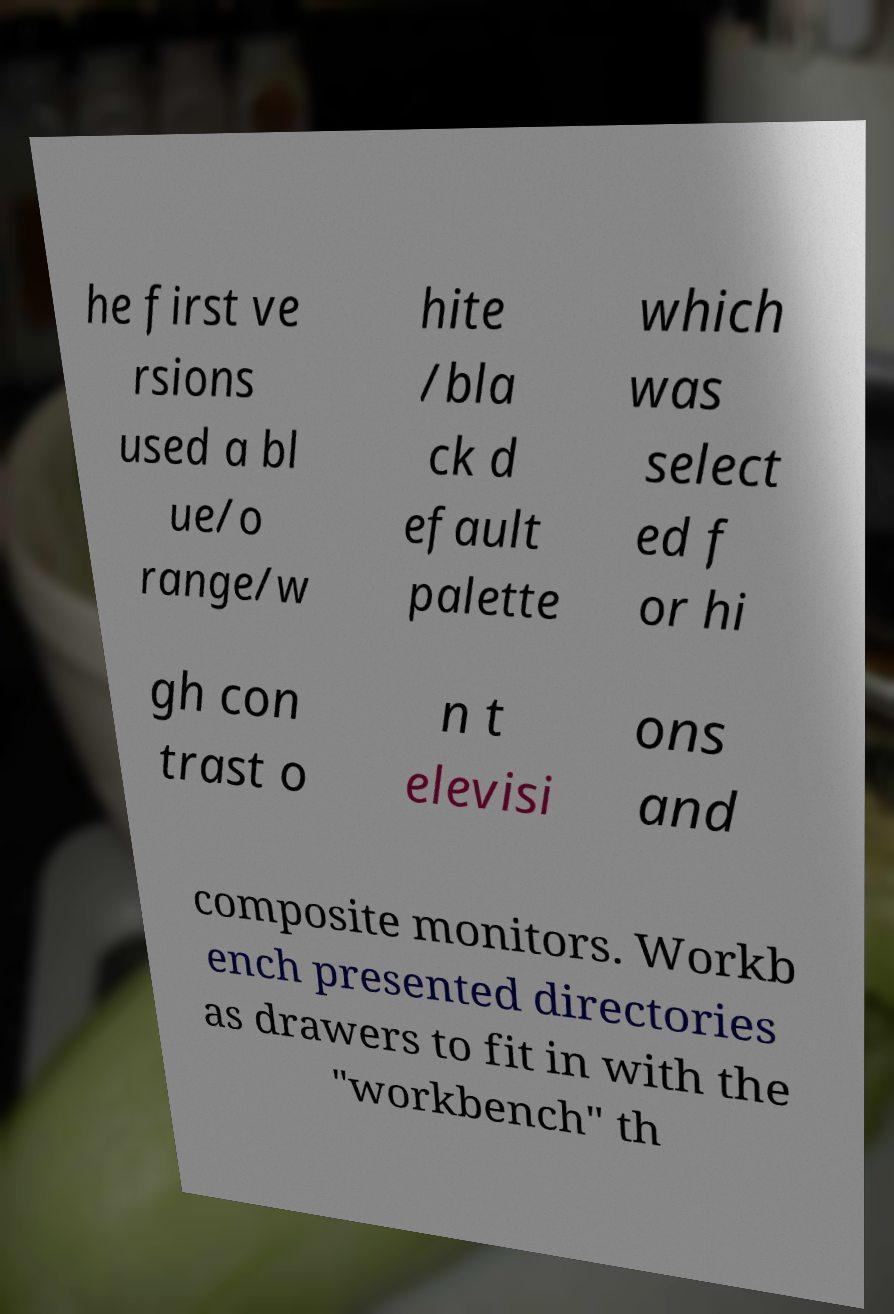Could you extract and type out the text from this image? he first ve rsions used a bl ue/o range/w hite /bla ck d efault palette which was select ed f or hi gh con trast o n t elevisi ons and composite monitors. Workb ench presented directories as drawers to fit in with the "workbench" th 